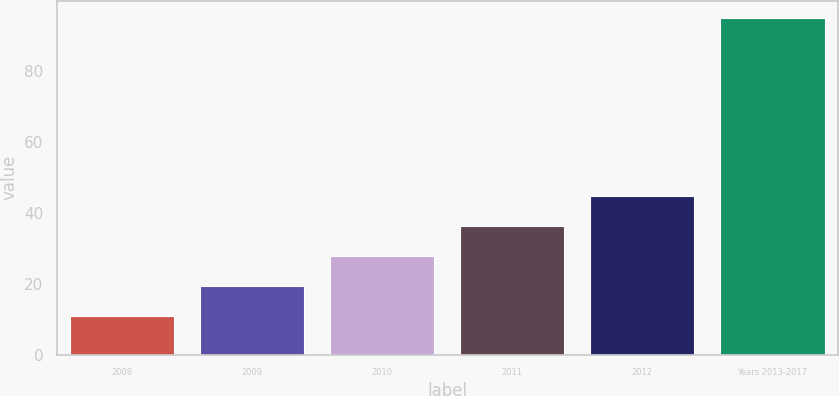<chart> <loc_0><loc_0><loc_500><loc_500><bar_chart><fcel>2008<fcel>2009<fcel>2010<fcel>2011<fcel>2012<fcel>Years 2013-2017<nl><fcel>11<fcel>19.4<fcel>27.8<fcel>36.2<fcel>44.6<fcel>95<nl></chart> 